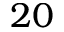Convert formula to latex. <formula><loc_0><loc_0><loc_500><loc_500>2 0</formula> 